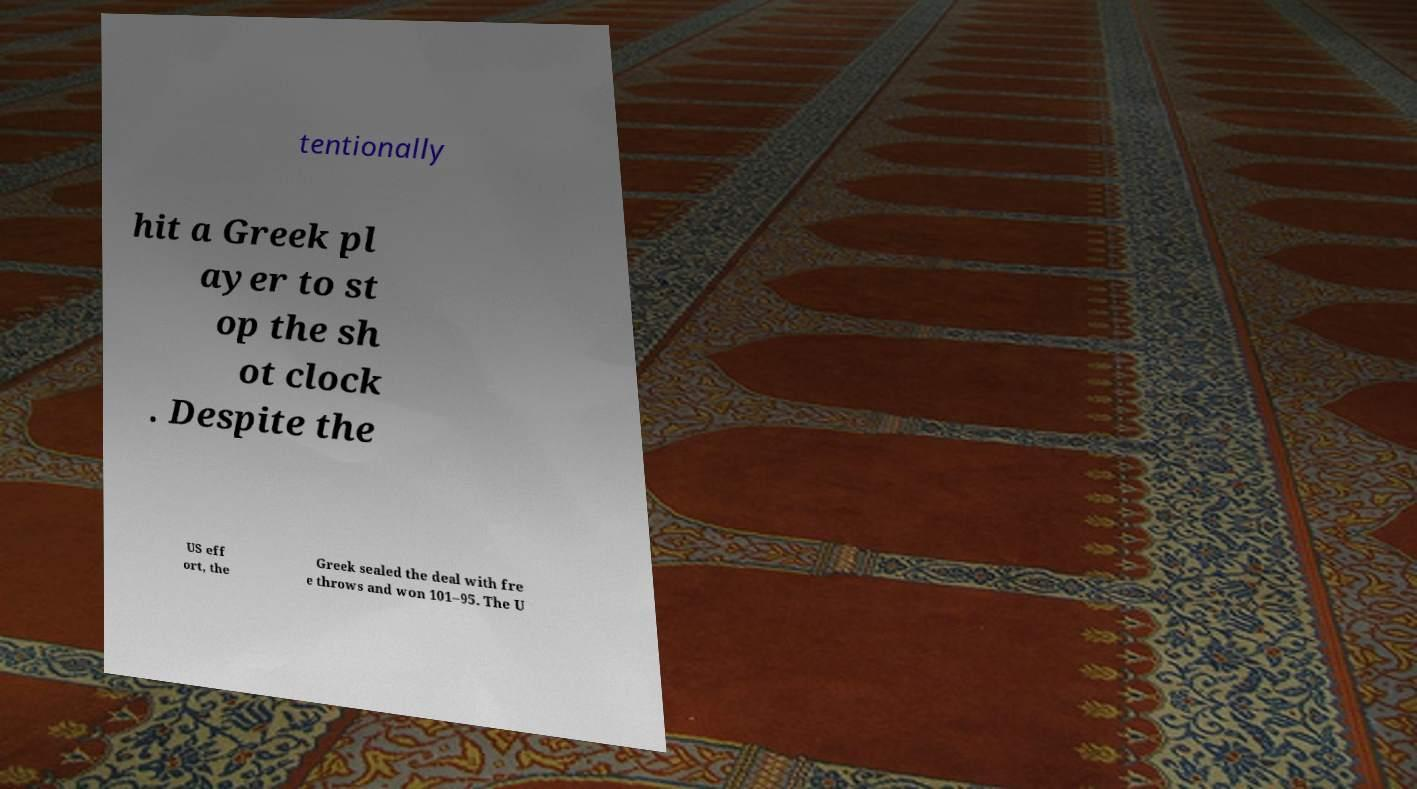Could you assist in decoding the text presented in this image and type it out clearly? tentionally hit a Greek pl ayer to st op the sh ot clock . Despite the US eff ort, the Greek sealed the deal with fre e throws and won 101–95. The U 